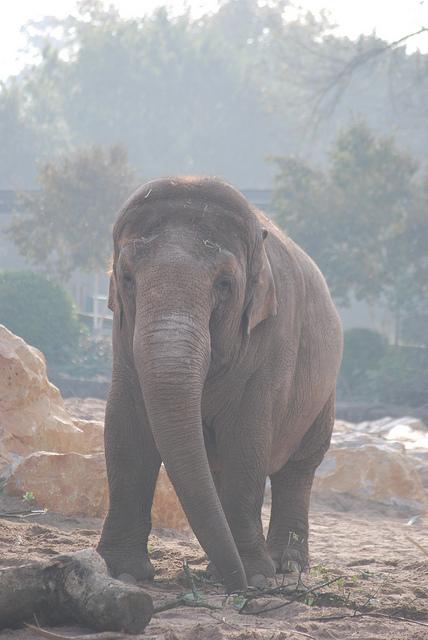Does the elephant like hot weather?
Concise answer only. No. Is there grass?
Short answer required. No. What animal is this?
Answer briefly. Elephant. Is the elephant in the wild?
Keep it brief. Yes. Is this animal real?
Be succinct. Yes. Is there more than one elephant?
Concise answer only. No. Where is the animal standing?
Keep it brief. Ground. 